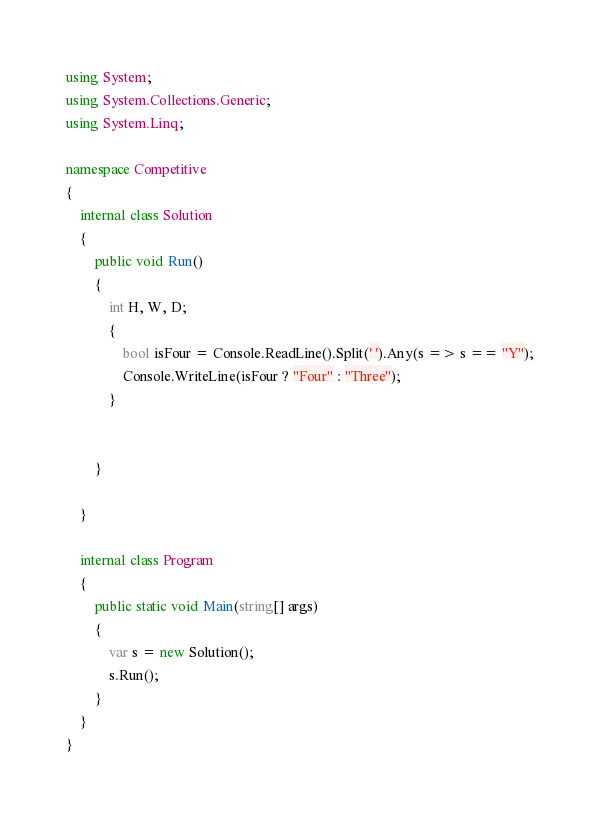<code> <loc_0><loc_0><loc_500><loc_500><_C#_>using System;
using System.Collections.Generic;
using System.Linq;

namespace Competitive
{
    internal class Solution
    {
        public void Run()
        {
            int H, W, D;
            {
                bool isFour = Console.ReadLine().Split(' ').Any(s => s == "Y");
                Console.WriteLine(isFour ? "Four" : "Three");
            }

           
        }

    }
    
    internal class Program
    {
        public static void Main(string[] args)
        {
            var s = new Solution();
            s.Run();
        }
    }
}</code> 